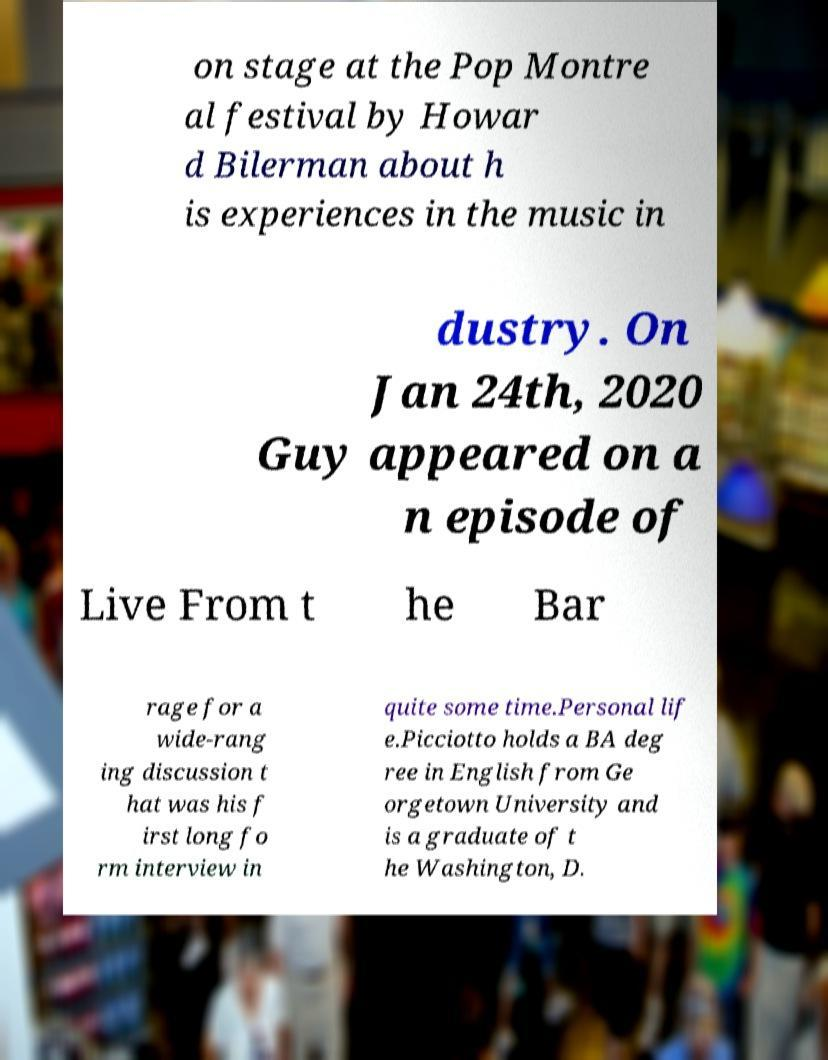Please identify and transcribe the text found in this image. on stage at the Pop Montre al festival by Howar d Bilerman about h is experiences in the music in dustry. On Jan 24th, 2020 Guy appeared on a n episode of Live From t he Bar rage for a wide-rang ing discussion t hat was his f irst long fo rm interview in quite some time.Personal lif e.Picciotto holds a BA deg ree in English from Ge orgetown University and is a graduate of t he Washington, D. 